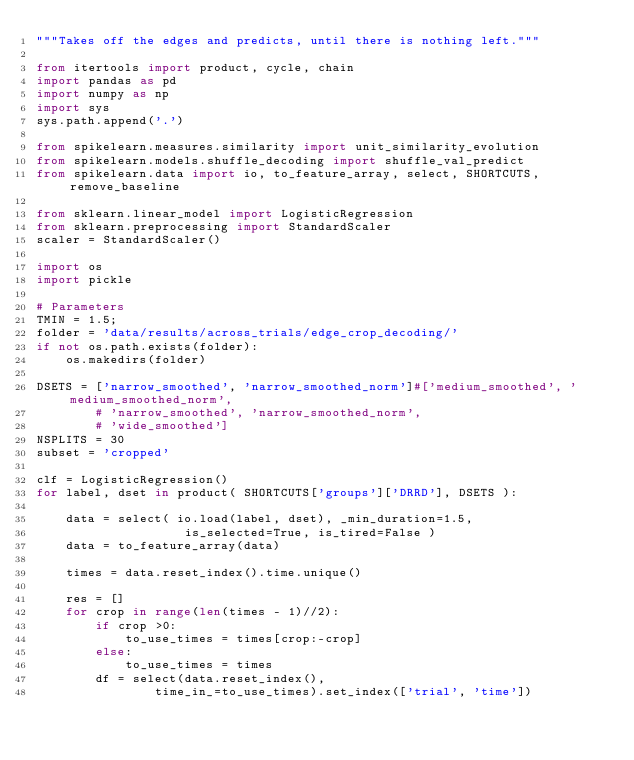<code> <loc_0><loc_0><loc_500><loc_500><_Python_>"""Takes off the edges and predicts, until there is nothing left."""

from itertools import product, cycle, chain
import pandas as pd
import numpy as np
import sys
sys.path.append('.')

from spikelearn.measures.similarity import unit_similarity_evolution
from spikelearn.models.shuffle_decoding import shuffle_val_predict
from spikelearn.data import io, to_feature_array, select, SHORTCUTS, remove_baseline

from sklearn.linear_model import LogisticRegression
from sklearn.preprocessing import StandardScaler
scaler = StandardScaler()

import os
import pickle

# Parameters
TMIN = 1.5;
folder = 'data/results/across_trials/edge_crop_decoding/'
if not os.path.exists(folder):
    os.makedirs(folder)

DSETS = ['narrow_smoothed', 'narrow_smoothed_norm']#['medium_smoothed', 'medium_smoothed_norm',
        # 'narrow_smoothed', 'narrow_smoothed_norm',
        # 'wide_smoothed']
NSPLITS = 30
subset = 'cropped'

clf = LogisticRegression()
for label, dset in product( SHORTCUTS['groups']['DRRD'], DSETS ):

    data = select( io.load(label, dset), _min_duration=1.5,
                    is_selected=True, is_tired=False )
    data = to_feature_array(data)

    times = data.reset_index().time.unique()

    res = []
    for crop in range(len(times - 1)//2):
        if crop >0:
            to_use_times = times[crop:-crop]
        else:
            to_use_times = times
        df = select(data.reset_index(),
                time_in_=to_use_times).set_index(['trial', 'time'])</code> 